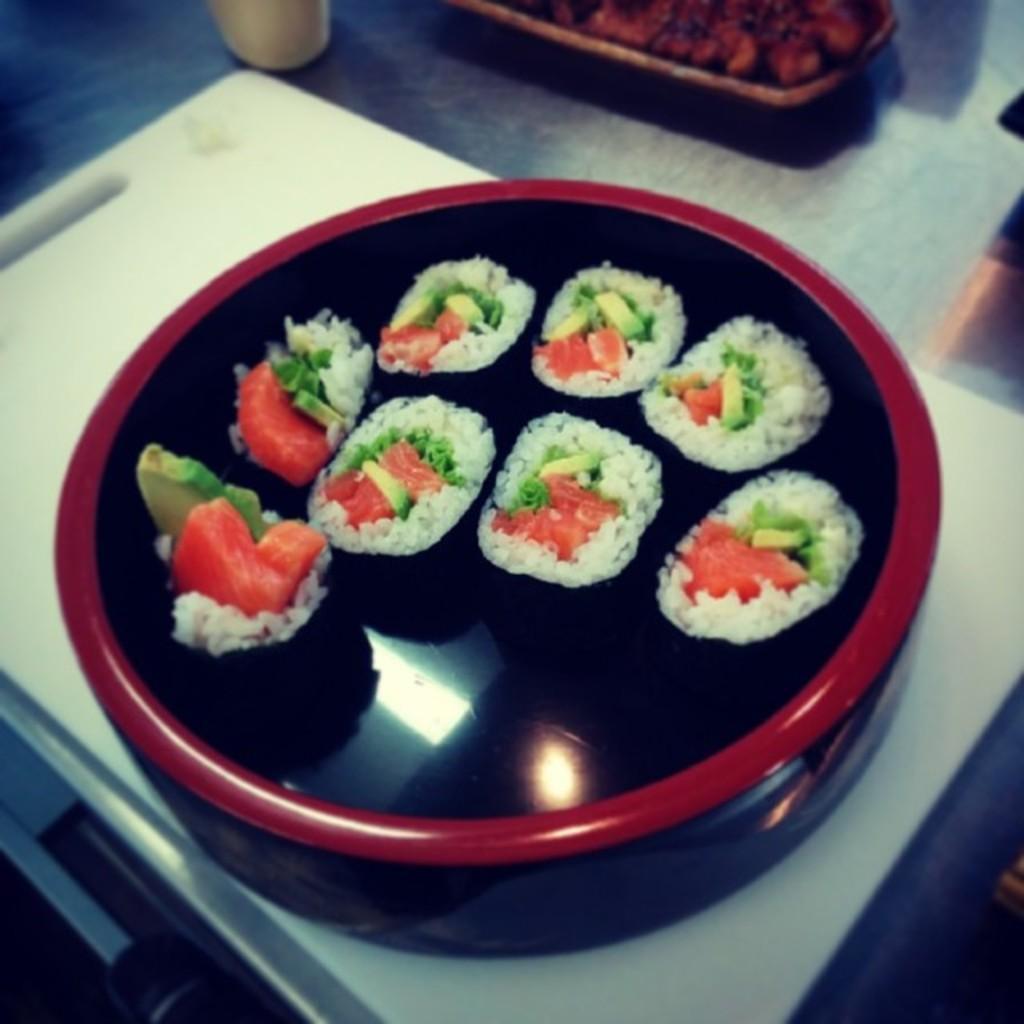Please provide a concise description of this image. In this image there is a box in which there are rice balls. The box is on the white cutter. At the top there is a cup on the left side and a tray with some food on the right side. 